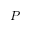<formula> <loc_0><loc_0><loc_500><loc_500>P</formula> 